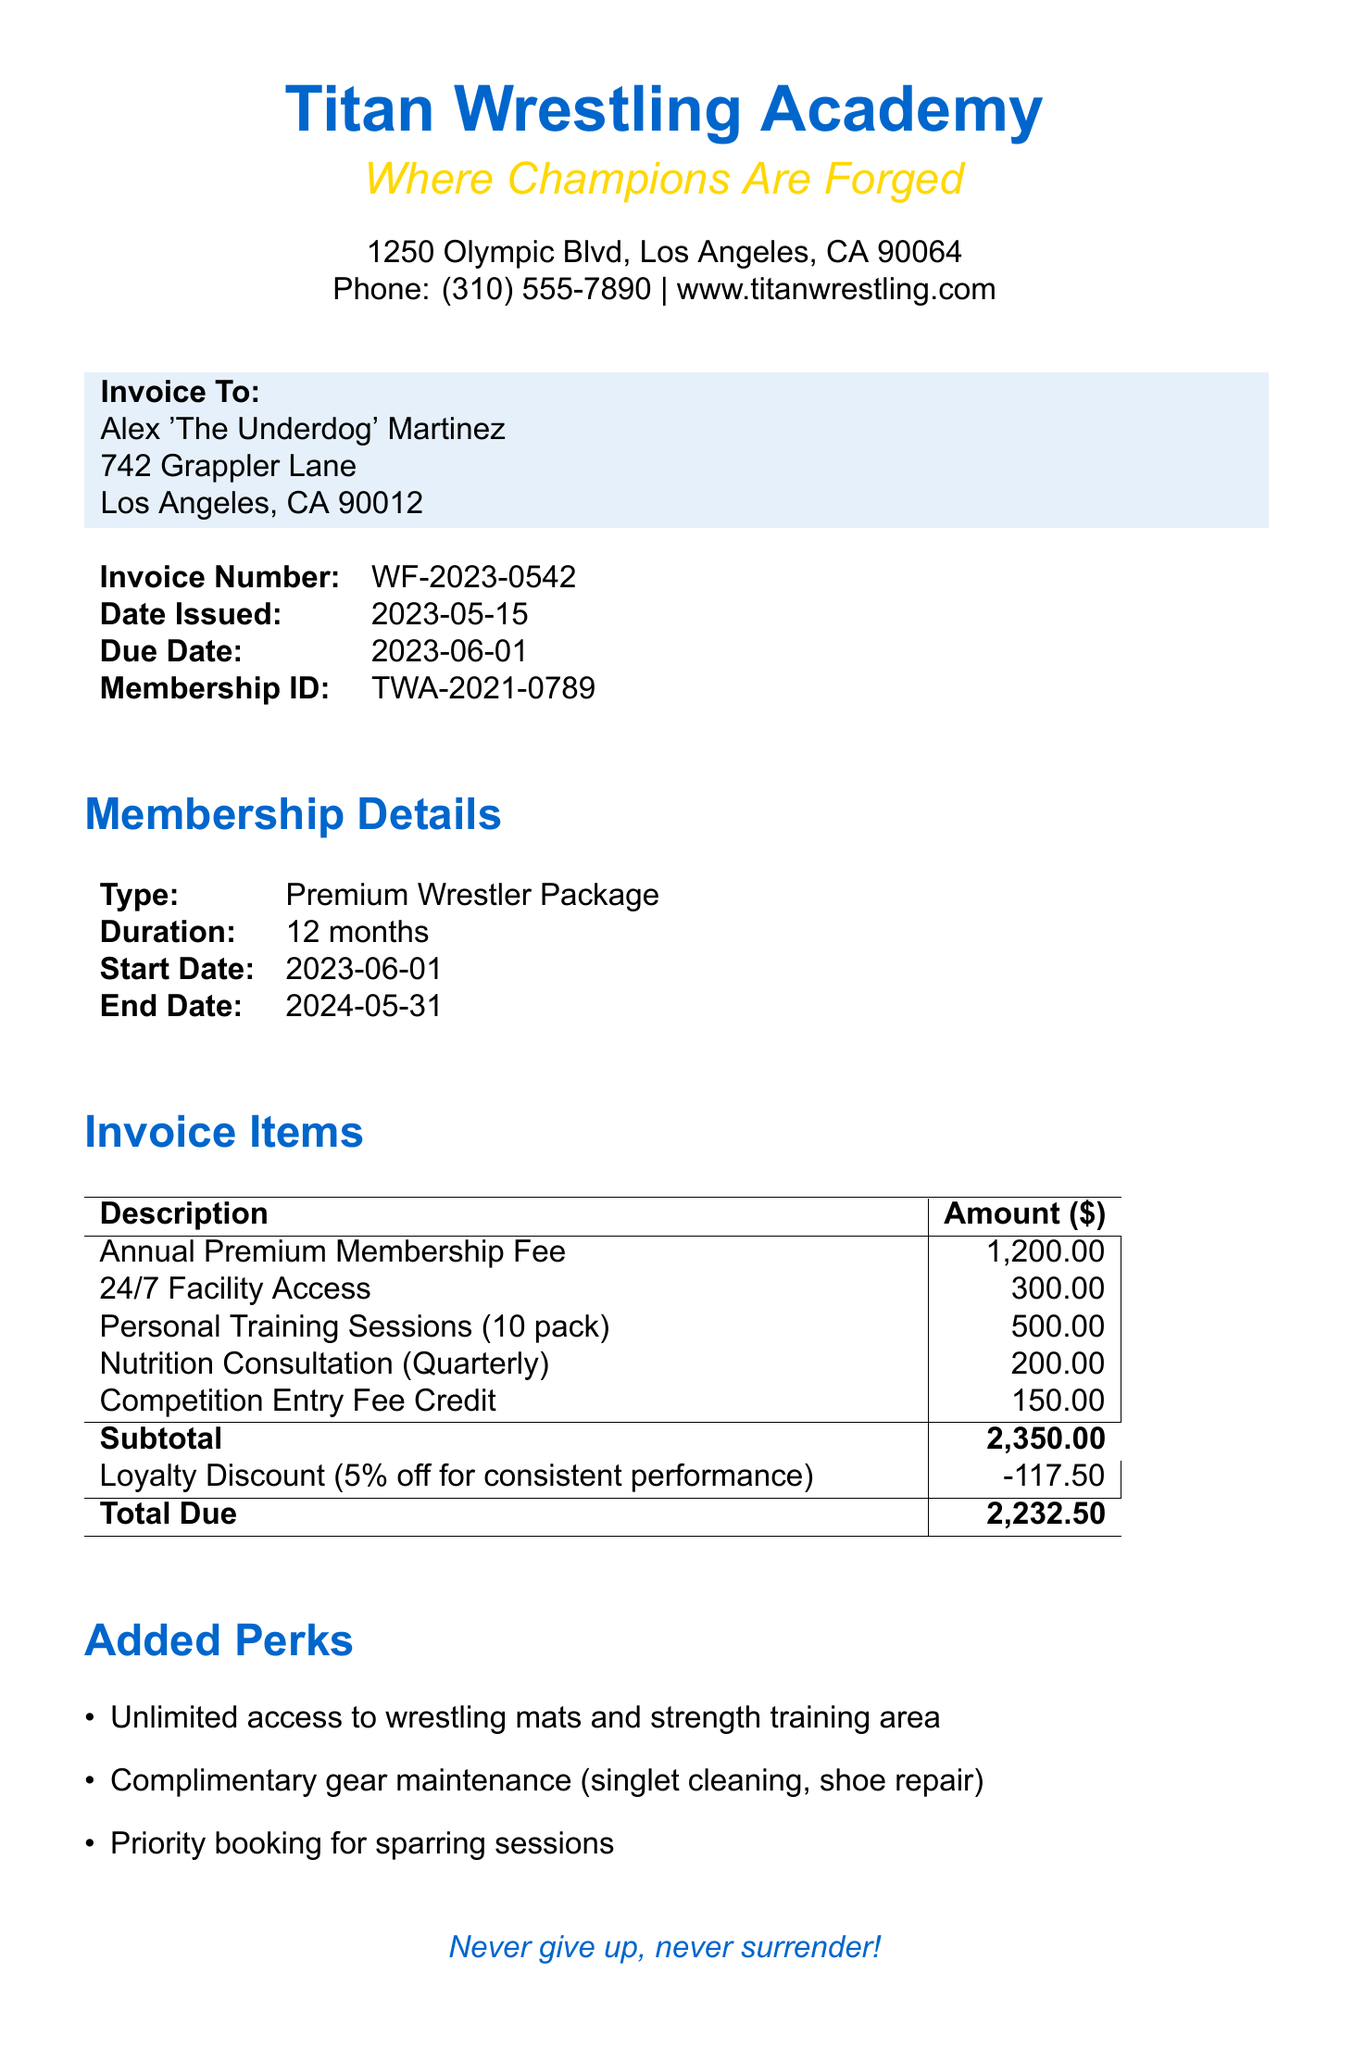What is the invoice number? The invoice number is a unique identifier for the billing document. In this case, it is WF-2023-0542.
Answer: WF-2023-0542 Who is the member for this invoice? The member's name is listed at the top of the invoice details, identifying the individual billed. In this case, it is Alex 'The Underdog' Martinez.
Answer: Alex 'The Underdog' Martinez What is the total due amount? The total due is the final amount after discounts and before payment, which can be found at the bottom of the invoice items section.
Answer: 2232.50 What is the start date of the membership? The start date indicates when the membership period begins, which is stated under membership details.
Answer: 2023-06-01 How much is the loyalty discount? This is the amount deducted due to the loyalty program, found next to the subtotal in the payment info section.
Answer: 117.50 What type of membership is being renewed? This indicates the level or type of membership provided to the individual. The invoice specifies it as the Premium Wrestler Package.
Answer: Premium Wrestler Package What is included in the added perks? This asks for specifics about the benefits that come with the membership, which can be found in their respective section.
Answer: Unlimited access to wrestling mats and strength training area What are the payment methods accepted? The invoice lists various payment options available for the member to choose from.
Answer: Credit Card, Bank Transfer, Cash What is the due date for this invoice? This refers to the last date the payment must be made to avoid penalties, noted in the invoice details.
Answer: 2023-06-01 